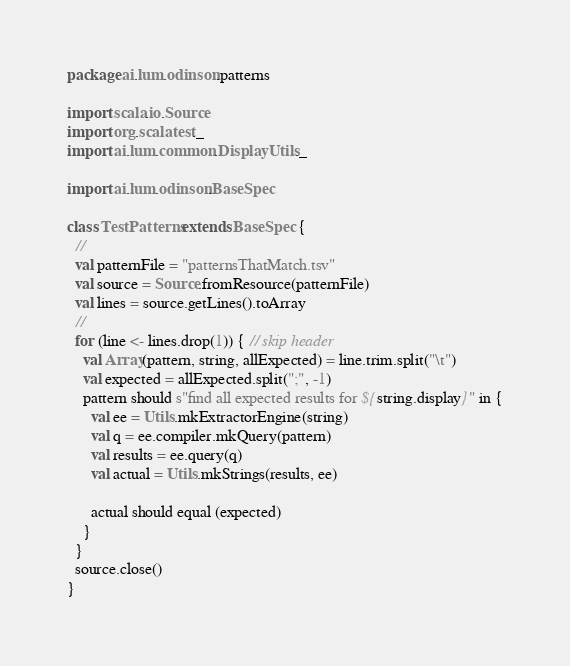<code> <loc_0><loc_0><loc_500><loc_500><_Scala_>package ai.lum.odinson.patterns

import scala.io.Source
import org.scalatest._
import ai.lum.common.DisplayUtils._

import ai.lum.odinson.BaseSpec

class TestPatterns extends BaseSpec {
  //
  val patternFile = "patternsThatMatch.tsv"
  val source = Source.fromResource(patternFile)
  val lines = source.getLines().toArray
  //
  for (line <- lines.drop(1)) { // skip header
    val Array(pattern, string, allExpected) = line.trim.split("\t")
    val expected = allExpected.split(";", -1)
    pattern should s"find all expected results for ${string.display}" in {
      val ee = Utils.mkExtractorEngine(string)
      val q = ee.compiler.mkQuery(pattern)
      val results = ee.query(q)
      val actual = Utils.mkStrings(results, ee)
      
      actual should equal (expected)
    }
  }
  source.close()
}
</code> 